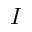Convert formula to latex. <formula><loc_0><loc_0><loc_500><loc_500>I</formula> 